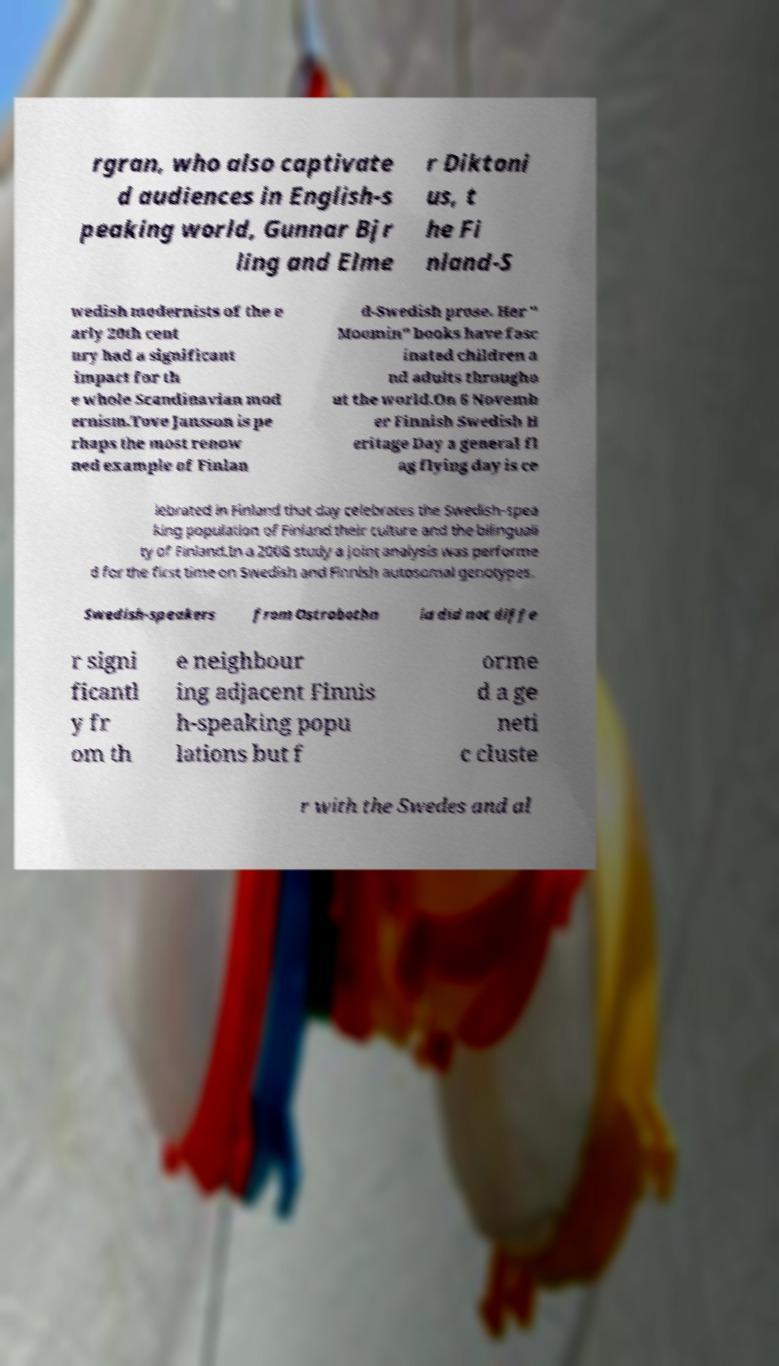Could you extract and type out the text from this image? rgran, who also captivate d audiences in English-s peaking world, Gunnar Bjr ling and Elme r Diktoni us, t he Fi nland-S wedish modernists of the e arly 20th cent ury had a significant impact for th e whole Scandinavian mod ernism.Tove Jansson is pe rhaps the most renow ned example of Finlan d-Swedish prose. Her " Moomin" books have fasc inated children a nd adults througho ut the world.On 6 Novemb er Finnish Swedish H eritage Day a general fl ag flying day is ce lebrated in Finland that day celebrates the Swedish-spea king population of Finland their culture and the bilinguali ty of Finland.In a 2008 study a joint analysis was performe d for the first time on Swedish and Finnish autosomal genotypes. Swedish-speakers from Ostrobothn ia did not diffe r signi ficantl y fr om th e neighbour ing adjacent Finnis h-speaking popu lations but f orme d a ge neti c cluste r with the Swedes and al 